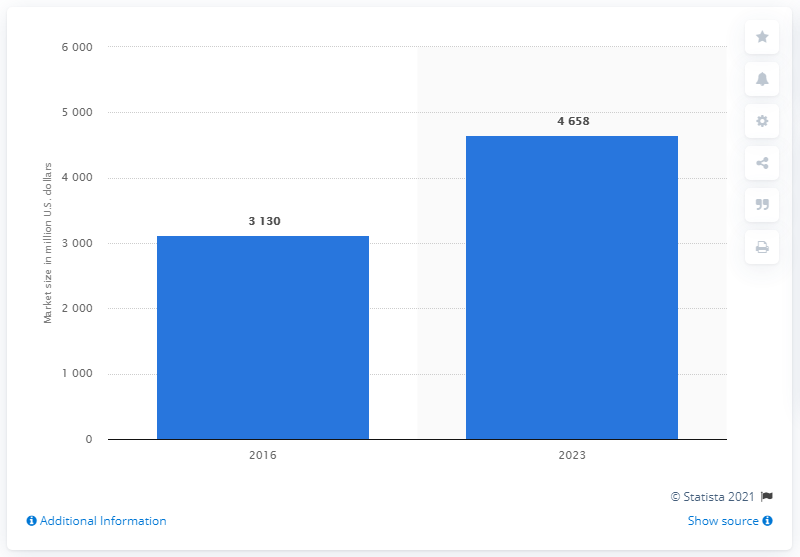Is there any additional information we can learn from this chart? Beyond the market size for 2016 and the projected figure for 2023, we're limited by what's visible in the chart. However, a 'Show source' link and an 'Additional Information' button suggest that there may be more data available on the source website to provide further insights into this forecast. 